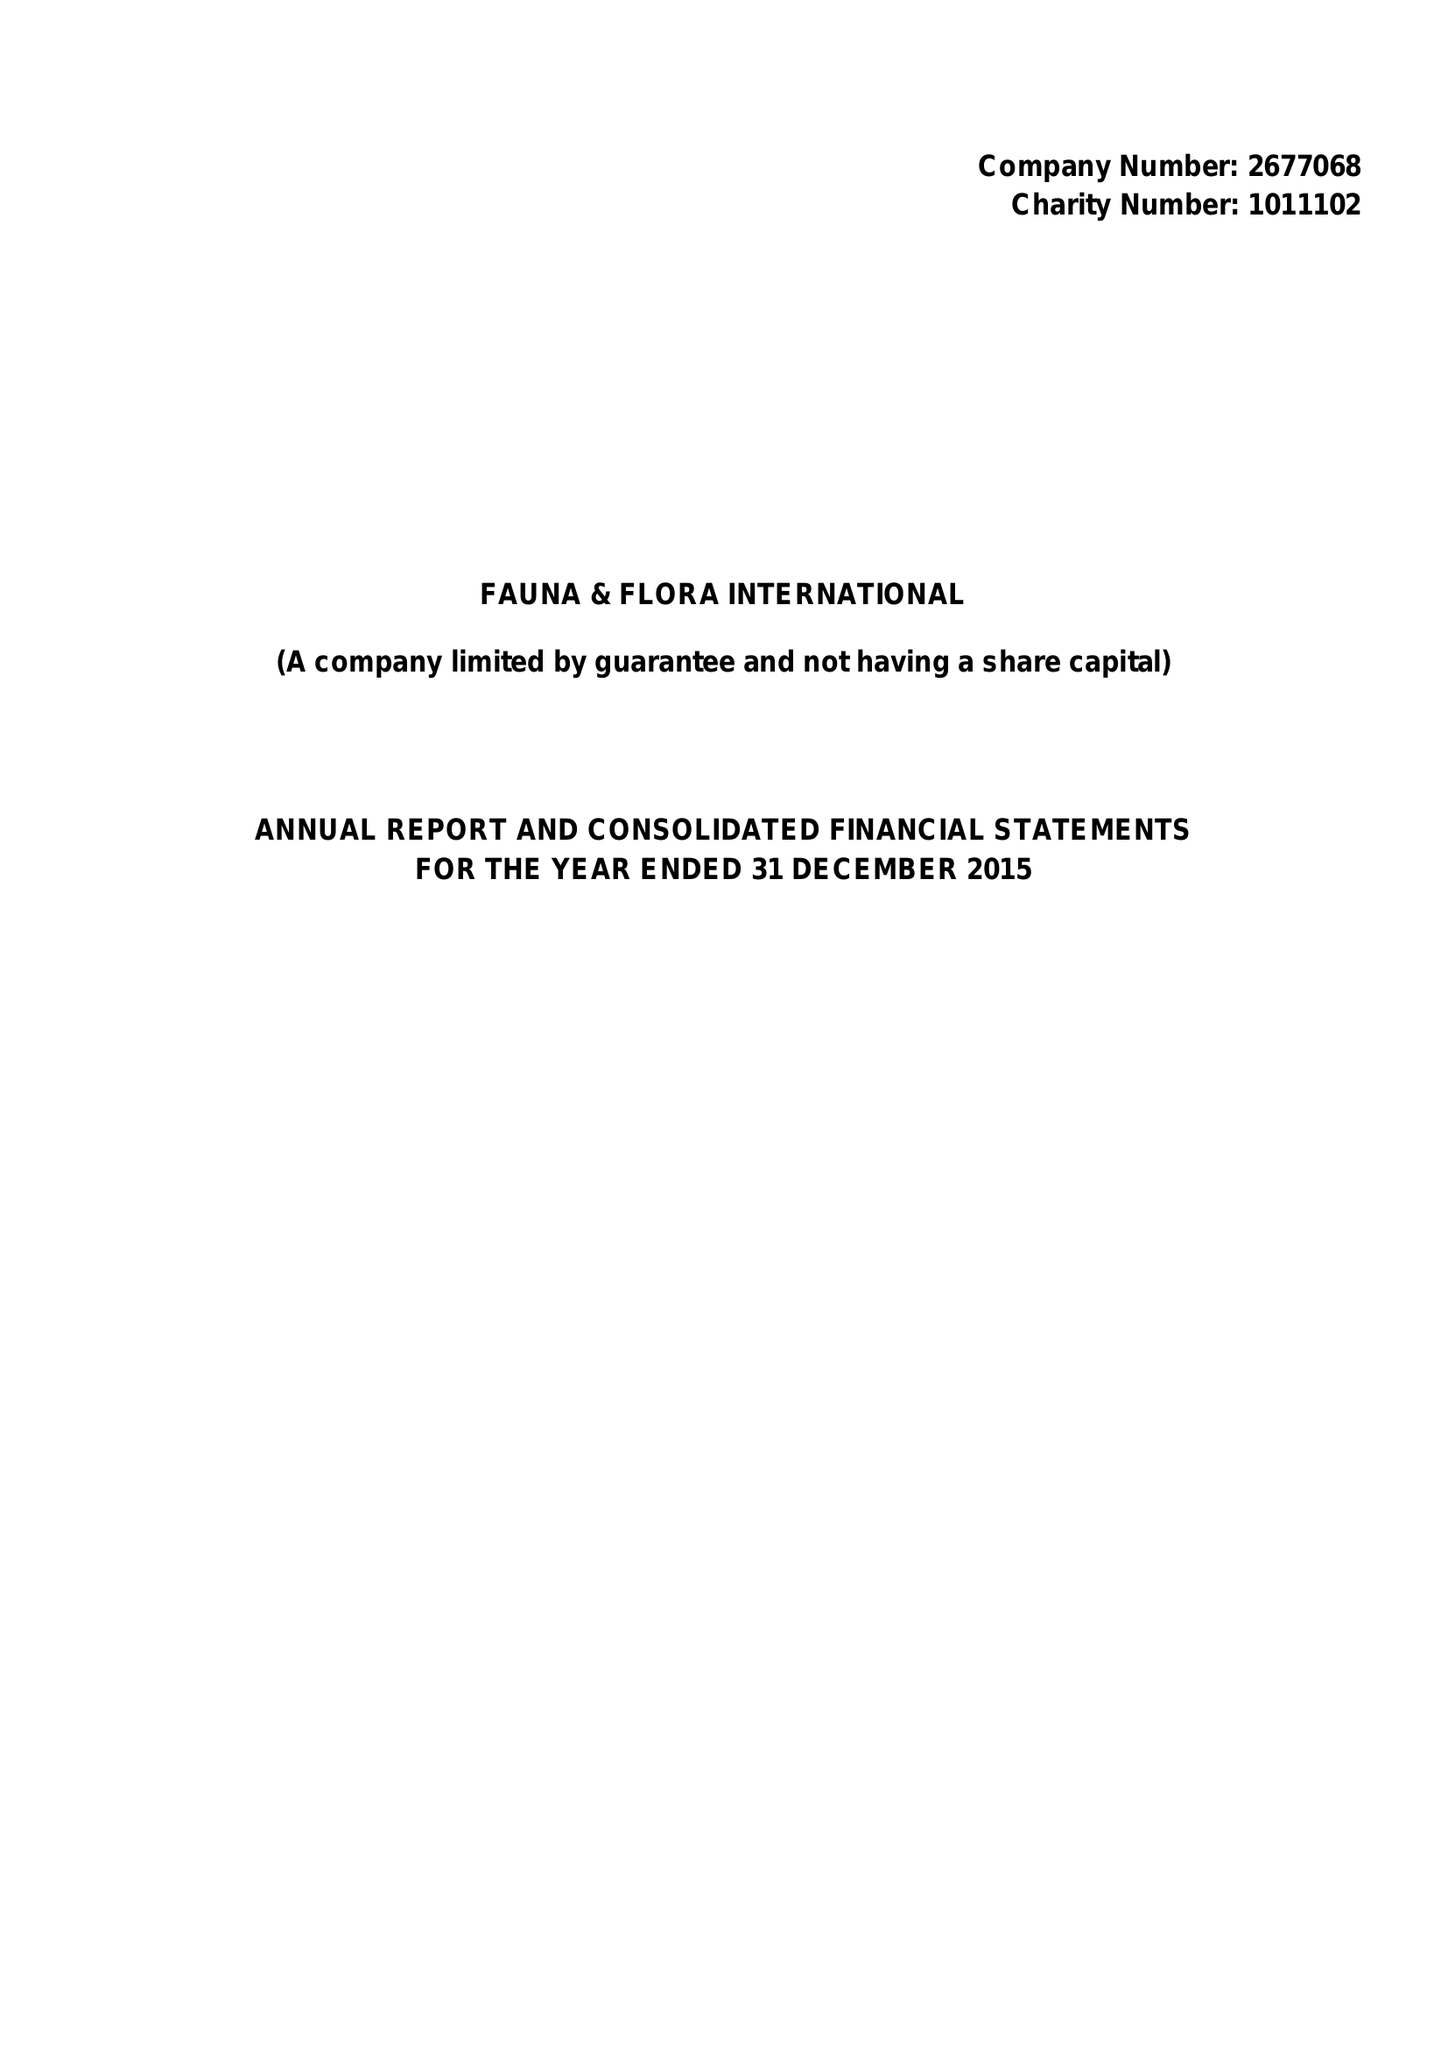What is the value for the charity_name?
Answer the question using a single word or phrase. Fauna and Flora International 